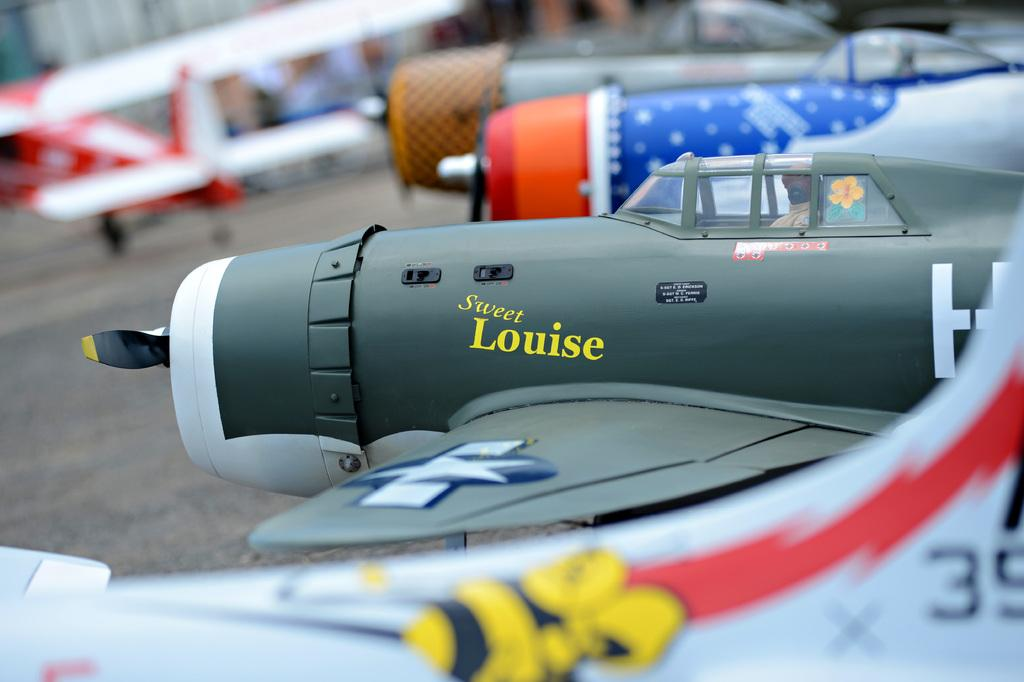<image>
Summarize the visual content of the image. A gray and white model fighter plane named Sweet Louise 